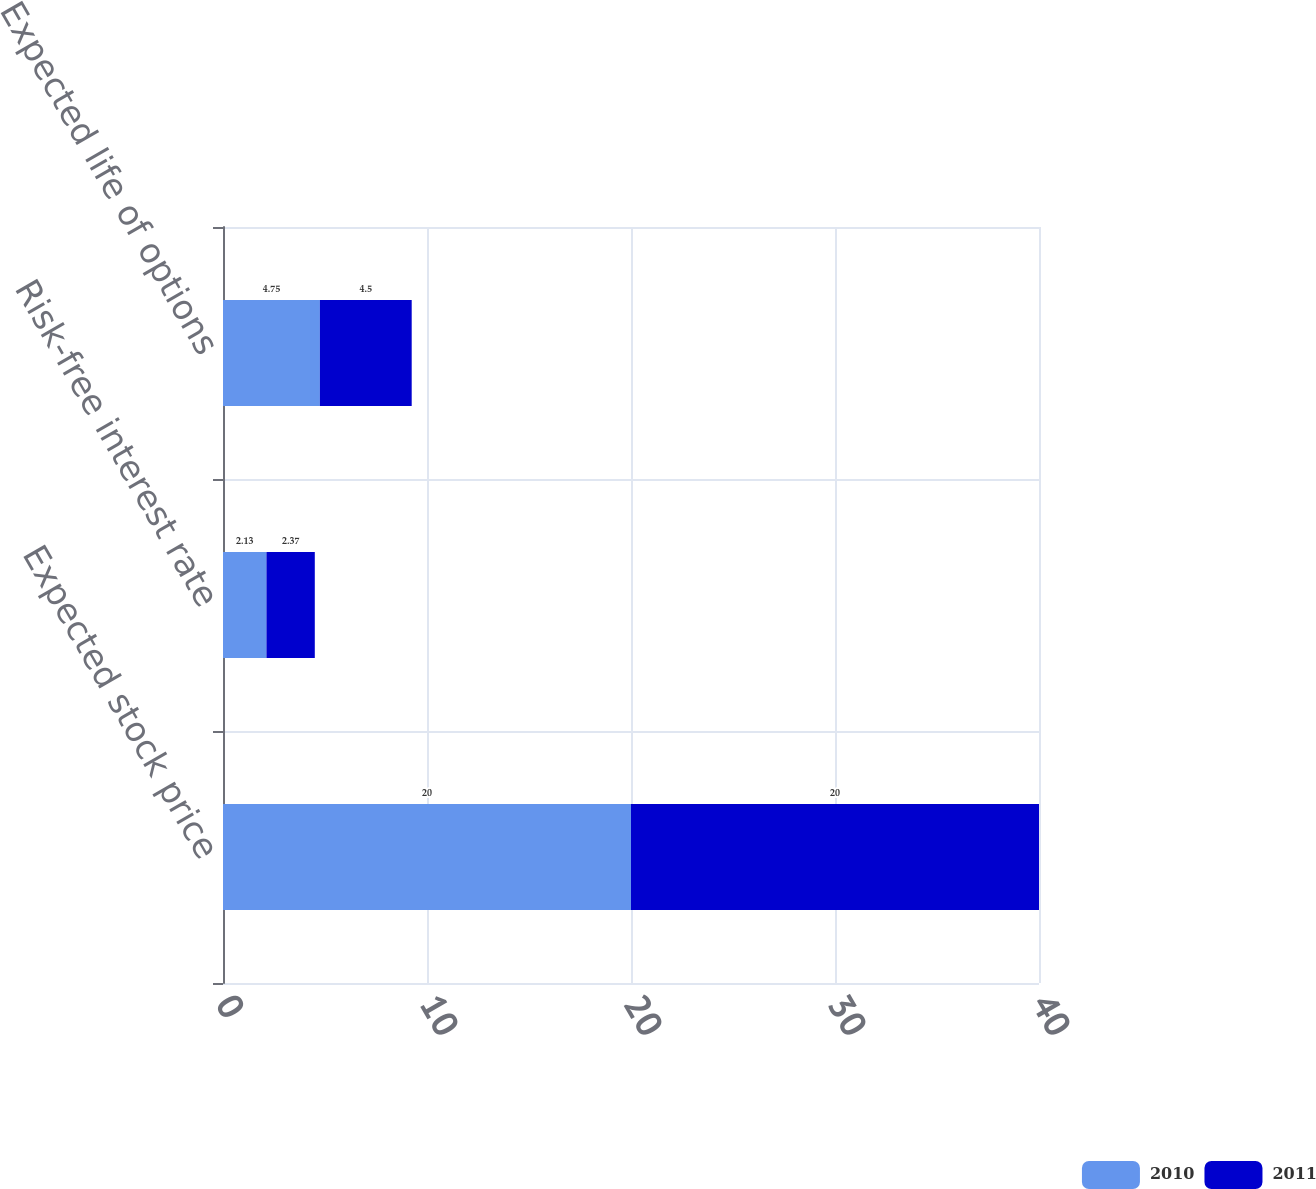Convert chart. <chart><loc_0><loc_0><loc_500><loc_500><stacked_bar_chart><ecel><fcel>Expected stock price<fcel>Risk-free interest rate<fcel>Expected life of options<nl><fcel>2010<fcel>20<fcel>2.13<fcel>4.75<nl><fcel>2011<fcel>20<fcel>2.37<fcel>4.5<nl></chart> 